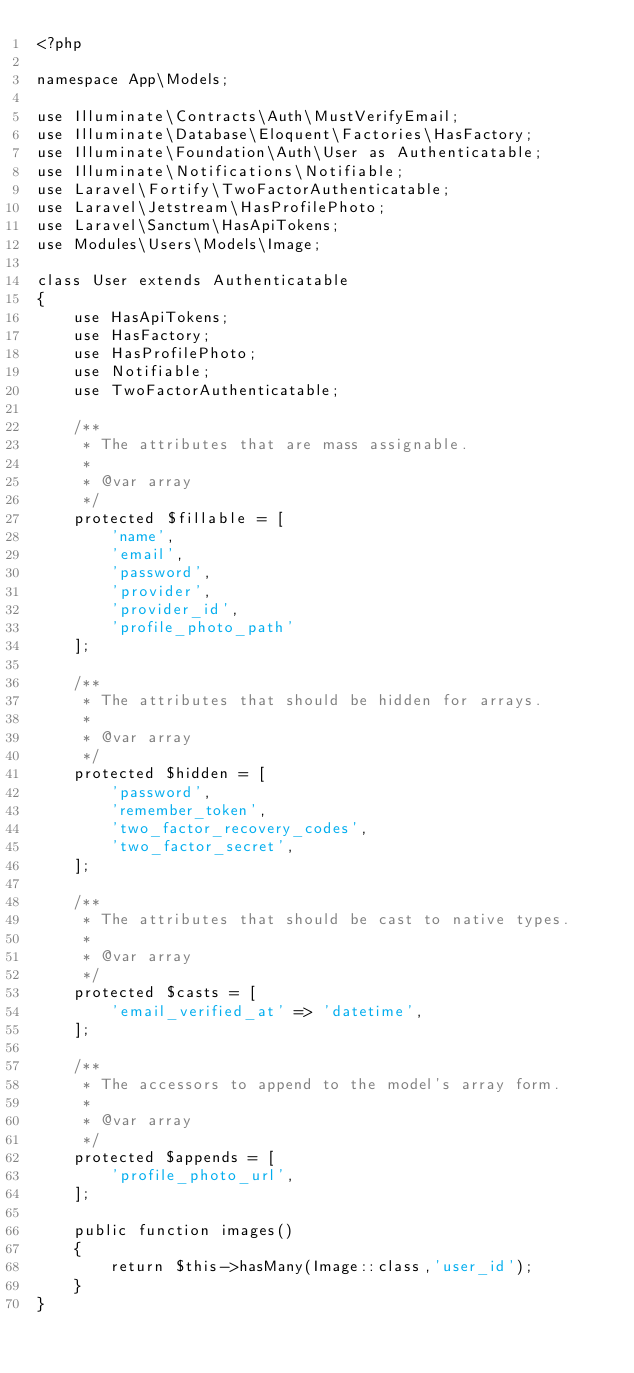<code> <loc_0><loc_0><loc_500><loc_500><_PHP_><?php

namespace App\Models;

use Illuminate\Contracts\Auth\MustVerifyEmail;
use Illuminate\Database\Eloquent\Factories\HasFactory;
use Illuminate\Foundation\Auth\User as Authenticatable;
use Illuminate\Notifications\Notifiable;
use Laravel\Fortify\TwoFactorAuthenticatable;
use Laravel\Jetstream\HasProfilePhoto;
use Laravel\Sanctum\HasApiTokens;
use Modules\Users\Models\Image;

class User extends Authenticatable
{
    use HasApiTokens;
    use HasFactory;
    use HasProfilePhoto;
    use Notifiable;
    use TwoFactorAuthenticatable;

    /**
     * The attributes that are mass assignable.
     *
     * @var array
     */
    protected $fillable = [
        'name',
        'email',
        'password',
        'provider',
        'provider_id',
        'profile_photo_path'
    ];

    /**
     * The attributes that should be hidden for arrays.
     *
     * @var array
     */
    protected $hidden = [
        'password',
        'remember_token',
        'two_factor_recovery_codes',
        'two_factor_secret',
    ];

    /**
     * The attributes that should be cast to native types.
     *
     * @var array
     */
    protected $casts = [
        'email_verified_at' => 'datetime',
    ];

    /**
     * The accessors to append to the model's array form.
     *
     * @var array
     */
    protected $appends = [
        'profile_photo_url',
    ];

    public function images()
    {
        return $this->hasMany(Image::class,'user_id');
    }
}
</code> 